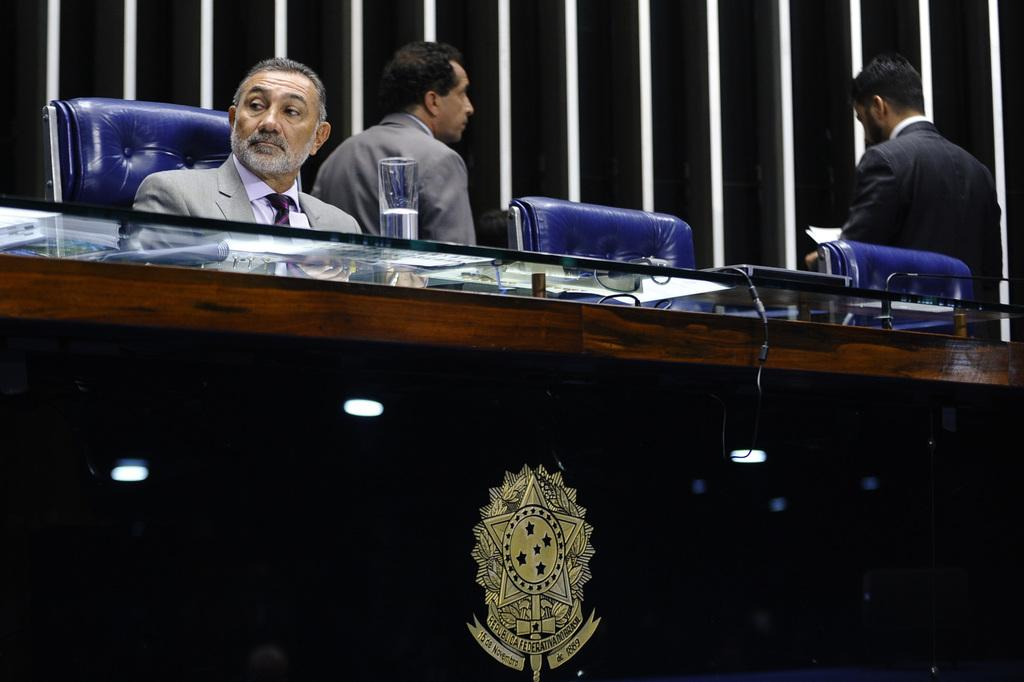How many people are in the image? There are people in the image, but the exact number is not specified. What is the position of one person in the image? One person is sitting on a chair in the image. What is present on the table in the image? There is a glass on the table, and there are objects on the table. What is the color scheme of the background in the image? The background of the image is in black and white color. What type of cloth is draped over the home in the image? There is no home or cloth present in the image. What is the tendency of the people in the image to engage in a specific activity? The facts provided do not give any information about the people's tendencies or activities. 